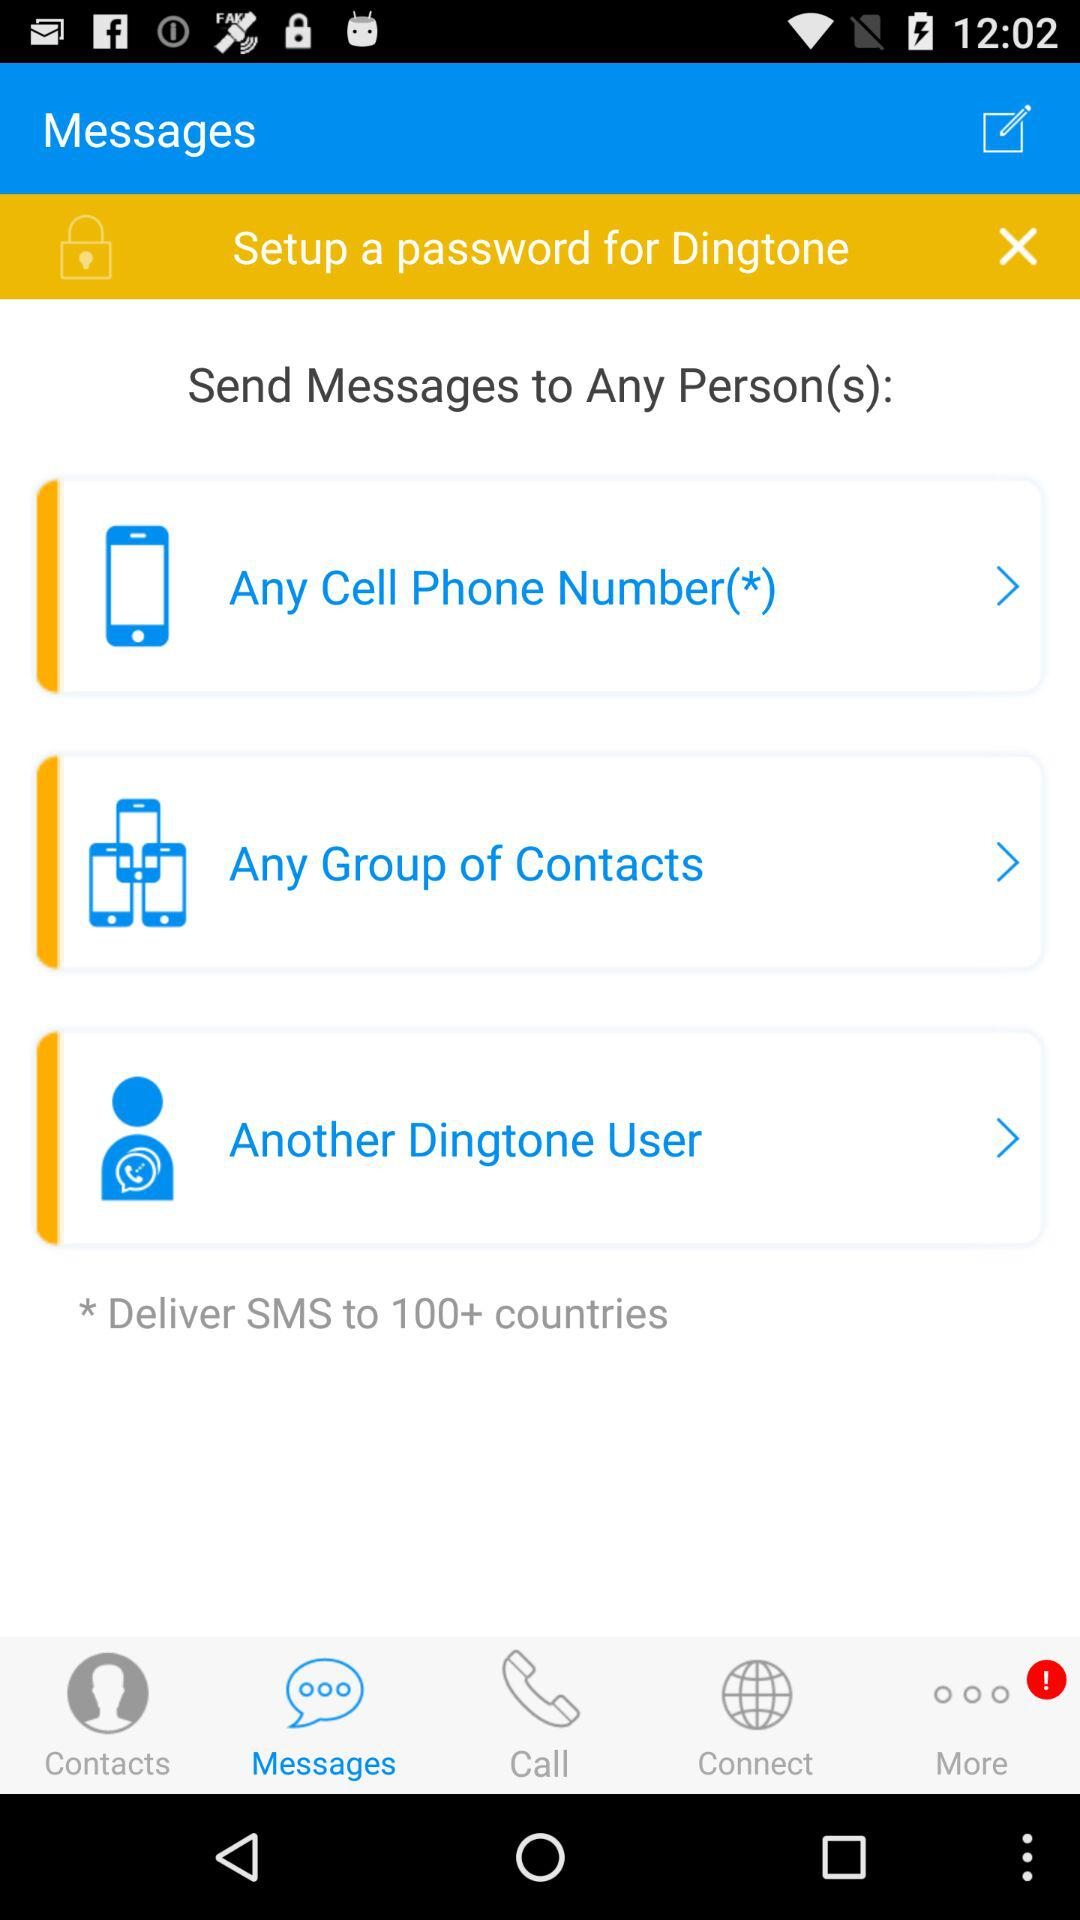How many countries are selected to send the message? There are more than 100 countries selected to send the message. 